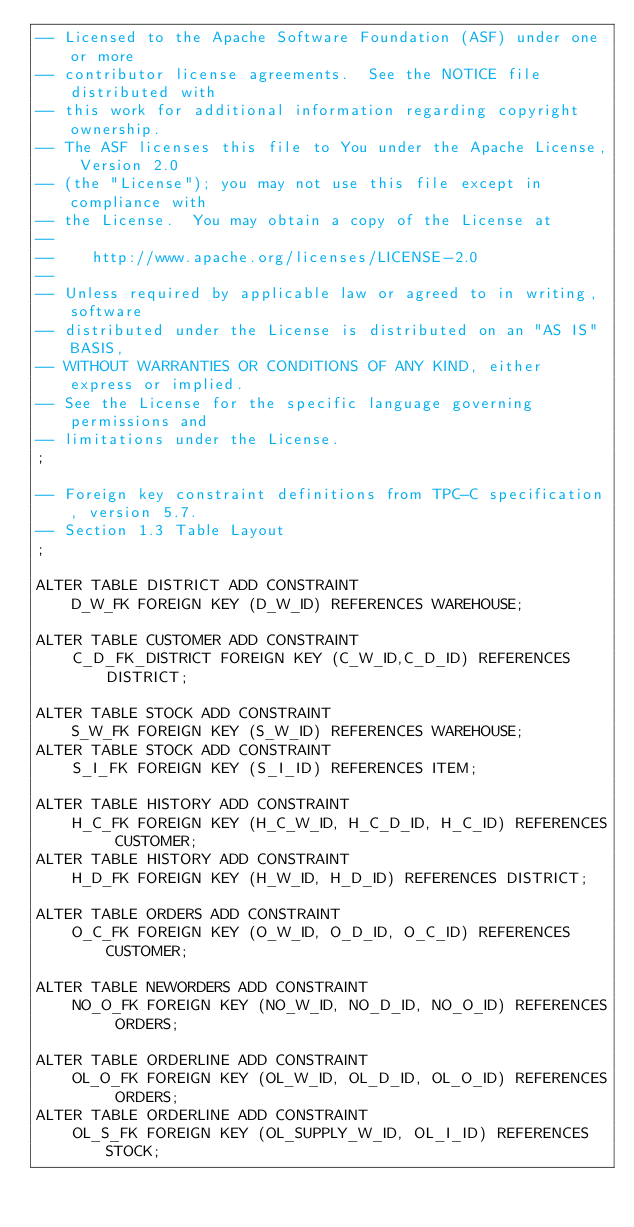<code> <loc_0><loc_0><loc_500><loc_500><_SQL_>-- Licensed to the Apache Software Foundation (ASF) under one or more
-- contributor license agreements.  See the NOTICE file distributed with
-- this work for additional information regarding copyright ownership.
-- The ASF licenses this file to You under the Apache License, Version 2.0
-- (the "License"); you may not use this file except in compliance with
-- the License.  You may obtain a copy of the License at
--
--    http://www.apache.org/licenses/LICENSE-2.0
--
-- Unless required by applicable law or agreed to in writing, software
-- distributed under the License is distributed on an "AS IS" BASIS,
-- WITHOUT WARRANTIES OR CONDITIONS OF ANY KIND, either express or implied.
-- See the License for the specific language governing permissions and
-- limitations under the License.
;

-- Foreign key constraint definitions from TPC-C specification, version 5.7.
-- Section 1.3 Table Layout
;

ALTER TABLE DISTRICT ADD CONSTRAINT
    D_W_FK FOREIGN KEY (D_W_ID) REFERENCES WAREHOUSE;

ALTER TABLE CUSTOMER ADD CONSTRAINT
    C_D_FK_DISTRICT FOREIGN KEY (C_W_ID,C_D_ID) REFERENCES DISTRICT;

ALTER TABLE STOCK ADD CONSTRAINT
    S_W_FK FOREIGN KEY (S_W_ID) REFERENCES WAREHOUSE;
ALTER TABLE STOCK ADD CONSTRAINT
    S_I_FK FOREIGN KEY (S_I_ID) REFERENCES ITEM;

ALTER TABLE HISTORY ADD CONSTRAINT
    H_C_FK FOREIGN KEY (H_C_W_ID, H_C_D_ID, H_C_ID) REFERENCES CUSTOMER;
ALTER TABLE HISTORY ADD CONSTRAINT
    H_D_FK FOREIGN KEY (H_W_ID, H_D_ID) REFERENCES DISTRICT;

ALTER TABLE ORDERS ADD CONSTRAINT
    O_C_FK FOREIGN KEY (O_W_ID, O_D_ID, O_C_ID) REFERENCES CUSTOMER;

ALTER TABLE NEWORDERS ADD CONSTRAINT
    NO_O_FK FOREIGN KEY (NO_W_ID, NO_D_ID, NO_O_ID) REFERENCES ORDERS;

ALTER TABLE ORDERLINE ADD CONSTRAINT
    OL_O_FK FOREIGN KEY (OL_W_ID, OL_D_ID, OL_O_ID) REFERENCES ORDERS;
ALTER TABLE ORDERLINE ADD CONSTRAINT
    OL_S_FK FOREIGN KEY (OL_SUPPLY_W_ID, OL_I_ID) REFERENCES STOCK;


</code> 